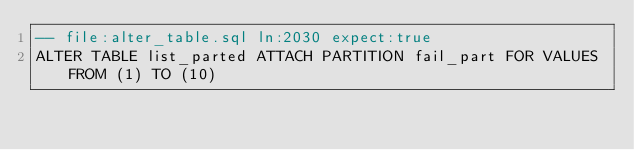Convert code to text. <code><loc_0><loc_0><loc_500><loc_500><_SQL_>-- file:alter_table.sql ln:2030 expect:true
ALTER TABLE list_parted ATTACH PARTITION fail_part FOR VALUES FROM (1) TO (10)
</code> 